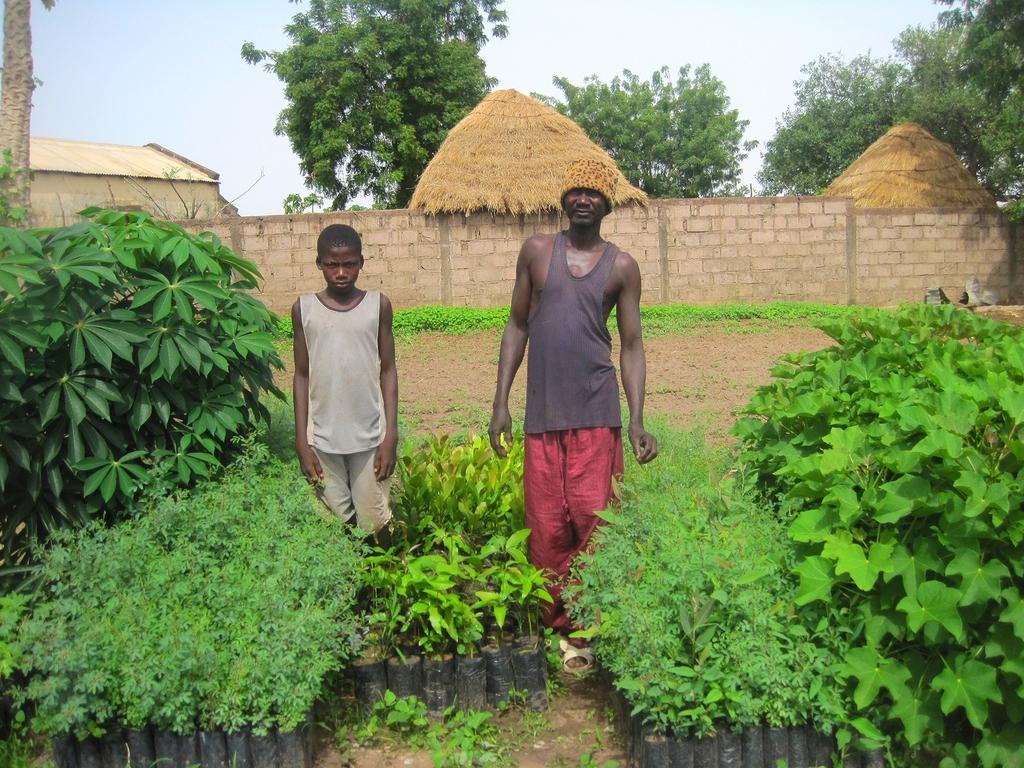Can you describe this image briefly? In the center of the image, we can see people standing and one of them is wearing a cap and in the background, there are trees, plants, sheds, some objects and there is a wall. At the top, there is sky. 